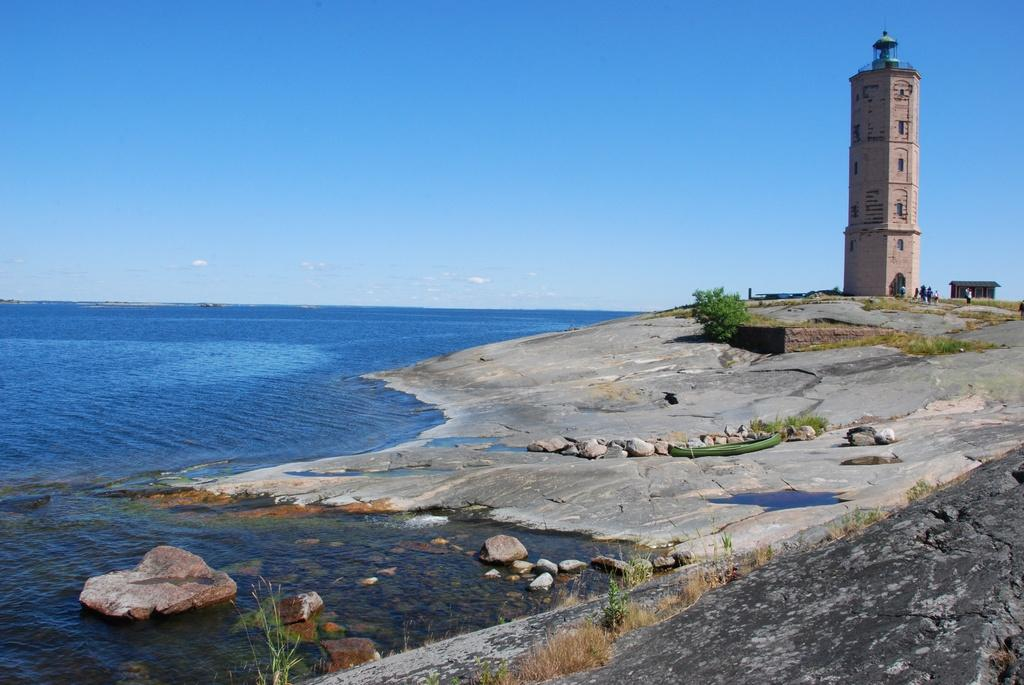What type of location is depicted in the image? There is a sea shore in the image. What structure can be seen near the sea shore? There is a tower in the image. How close is the tower to the sea shore? The tower is located near the sea shore. Are there any people present in the image? Yes, there are people standing near the tower. What time of day is indicated by the hour on the tower in the image? There is no hour or clock visible on the tower in the image. What type of flesh can be seen on the people standing near the tower? There is no flesh visible on the people standing near the tower; they are fully clothed. What color is the orange that is being peeled by the people near the tower? There is no orange present in the image; the people are not peeling any fruit. 